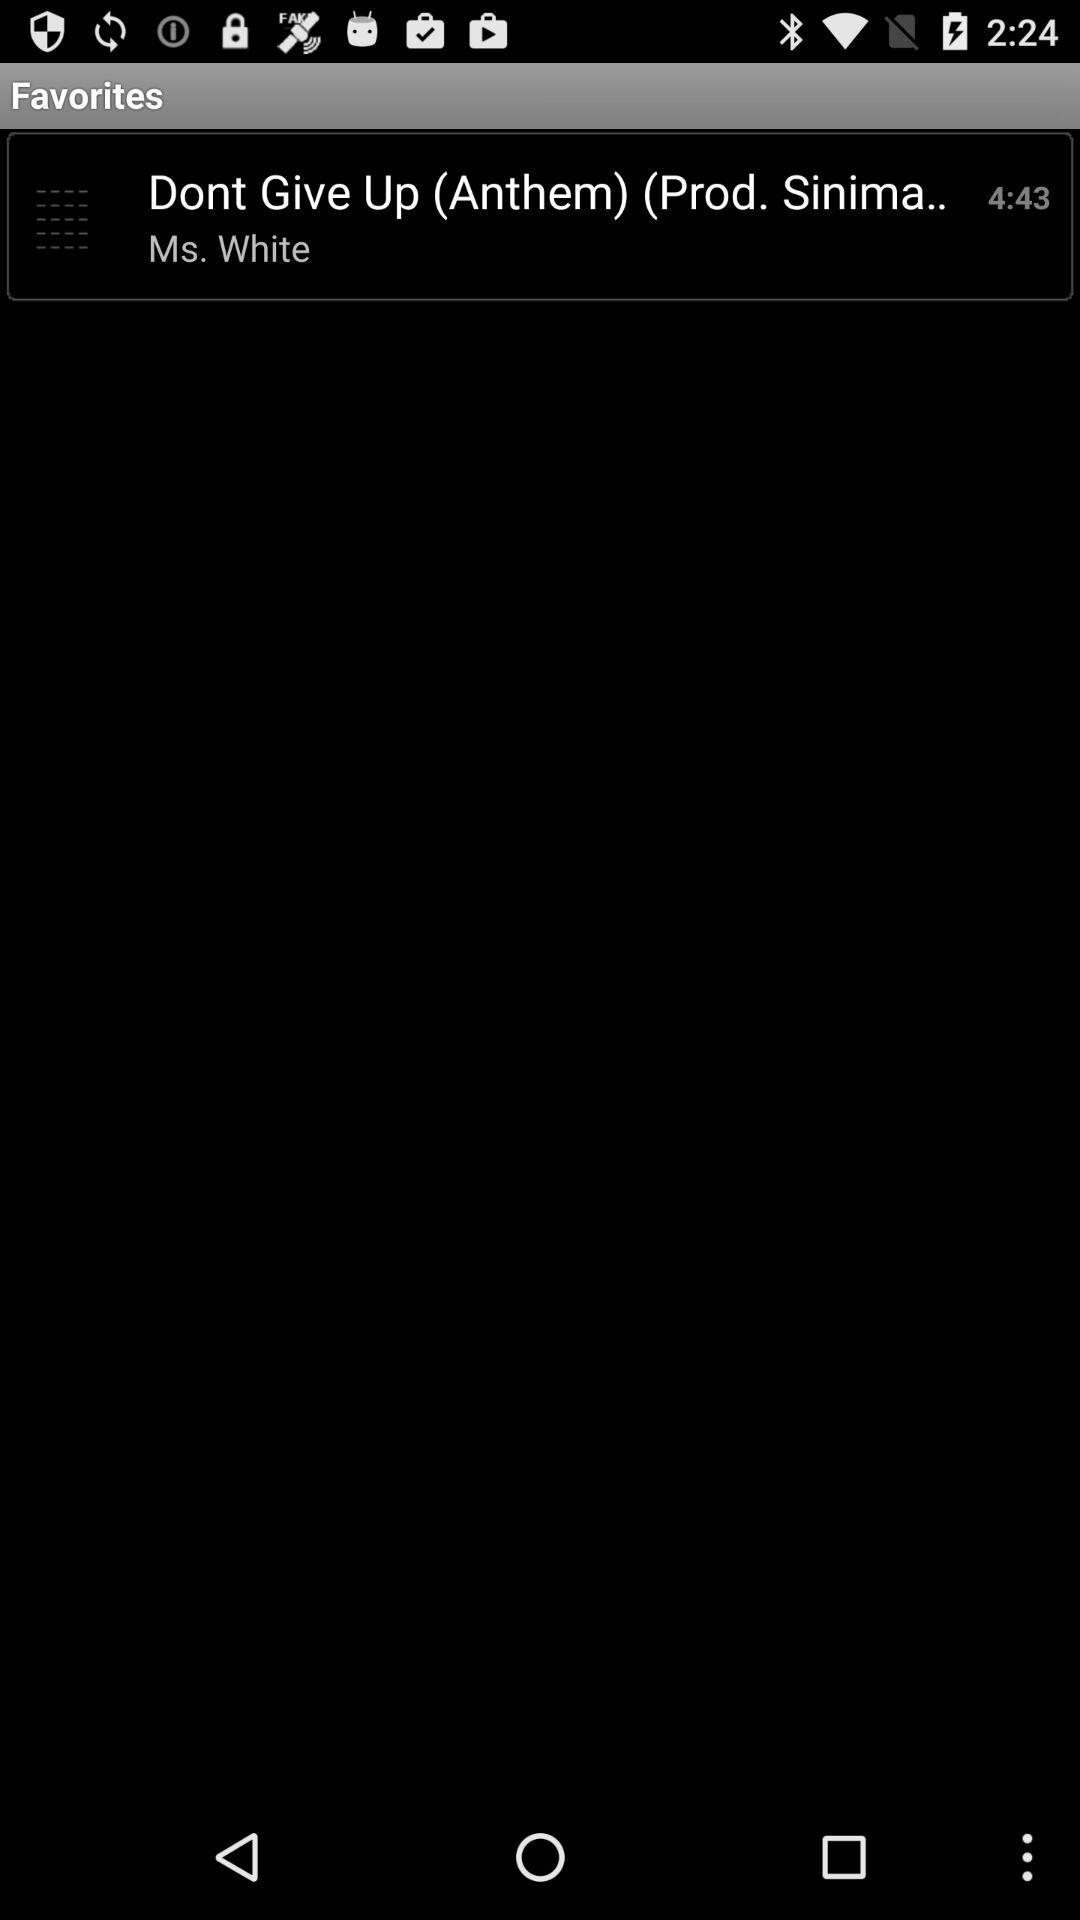What is the title of the anthem? The title of the anthem is "Dont Give Up". 